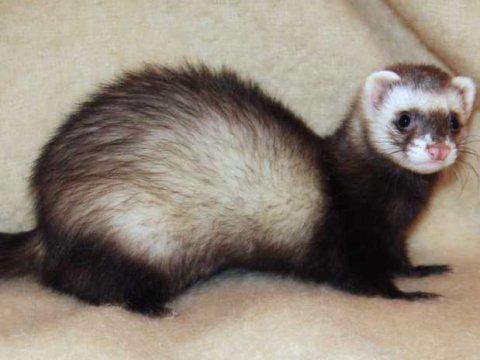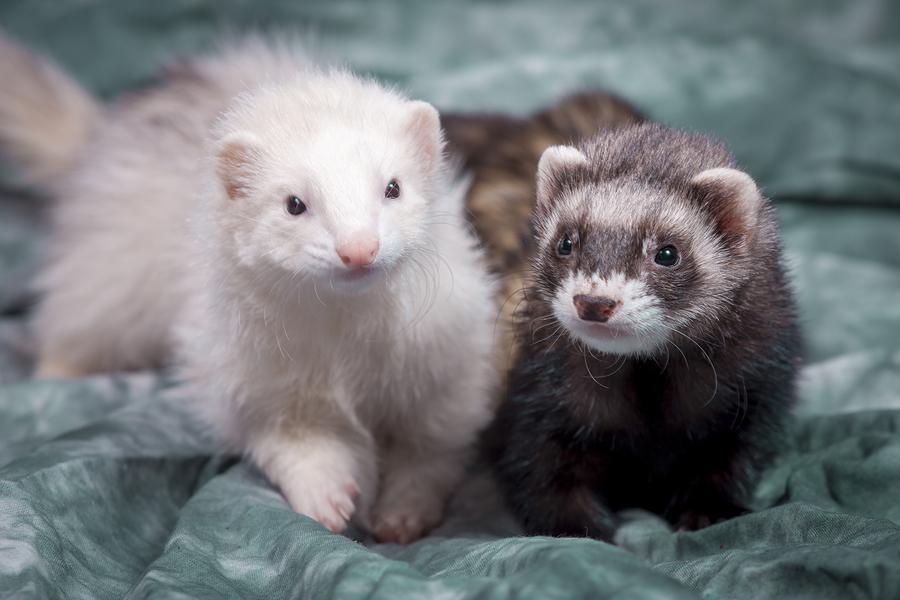The first image is the image on the left, the second image is the image on the right. Evaluate the accuracy of this statement regarding the images: "The right image shows just one ferret, and it has a mottled brown nose.". Is it true? Answer yes or no. No. 